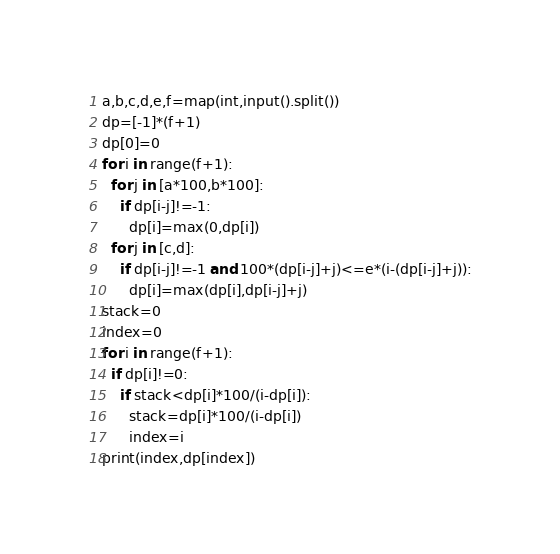<code> <loc_0><loc_0><loc_500><loc_500><_Python_>a,b,c,d,e,f=map(int,input().split())
dp=[-1]*(f+1)
dp[0]=0
for i in range(f+1):
  for j in [a*100,b*100]:
    if dp[i-j]!=-1:
      dp[i]=max(0,dp[i])
  for j in [c,d]:
    if dp[i-j]!=-1 and 100*(dp[i-j]+j)<=e*(i-(dp[i-j]+j)):
      dp[i]=max(dp[i],dp[i-j]+j)
stack=0
index=0
for i in range(f+1):
  if dp[i]!=0:
    if stack<dp[i]*100/(i-dp[i]):
      stack=dp[i]*100/(i-dp[i])
      index=i
print(index,dp[index])</code> 